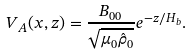<formula> <loc_0><loc_0><loc_500><loc_500>V _ { A } ( x , z ) = \frac { { B _ { 0 0 } } } { { \sqrt { \mu _ { 0 } \hat { \rho } _ { 0 } } } } e ^ { - z / H _ { b } } .</formula> 